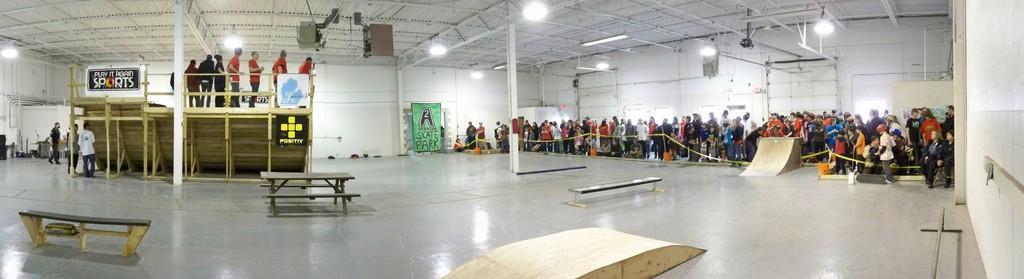In one or two sentences, can you explain what this image depicts? On the left side of the image we can see benches and staircase. There are people standing on the staircase. In the center there is a board. On the right there is a ramp an we can see crowd. At the top there are lights. In the background there is a wall. 